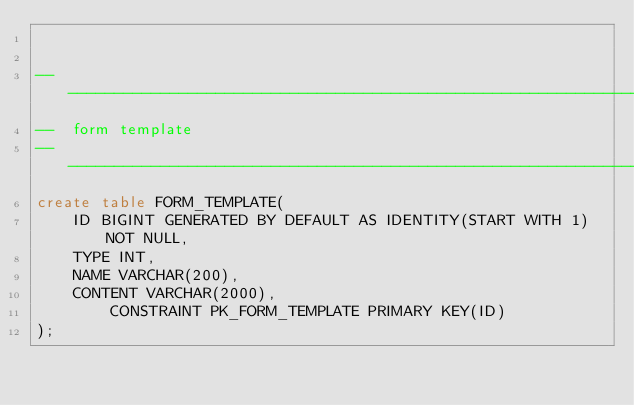Convert code to text. <code><loc_0><loc_0><loc_500><loc_500><_SQL_>

-------------------------------------------------------------------------------
--  form template
-------------------------------------------------------------------------------
create table FORM_TEMPLATE(
	ID BIGINT GENERATED BY DEFAULT AS IDENTITY(START WITH 1) NOT NULL,
	TYPE INT,
	NAME VARCHAR(200),
	CONTENT VARCHAR(2000),
        CONSTRAINT PK_FORM_TEMPLATE PRIMARY KEY(ID)
);

</code> 